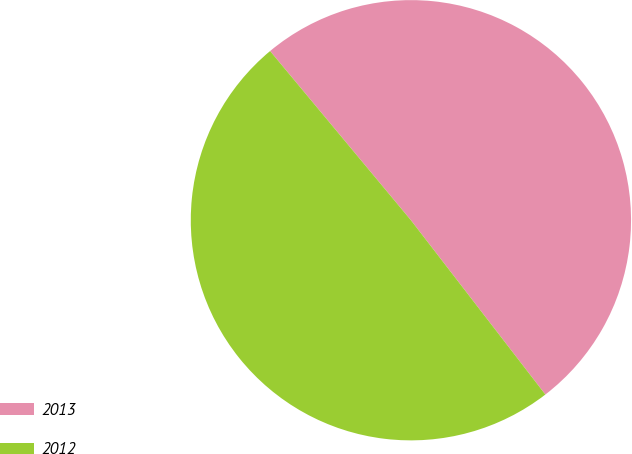Convert chart to OTSL. <chart><loc_0><loc_0><loc_500><loc_500><pie_chart><fcel>2013<fcel>2012<nl><fcel>50.59%<fcel>49.41%<nl></chart> 